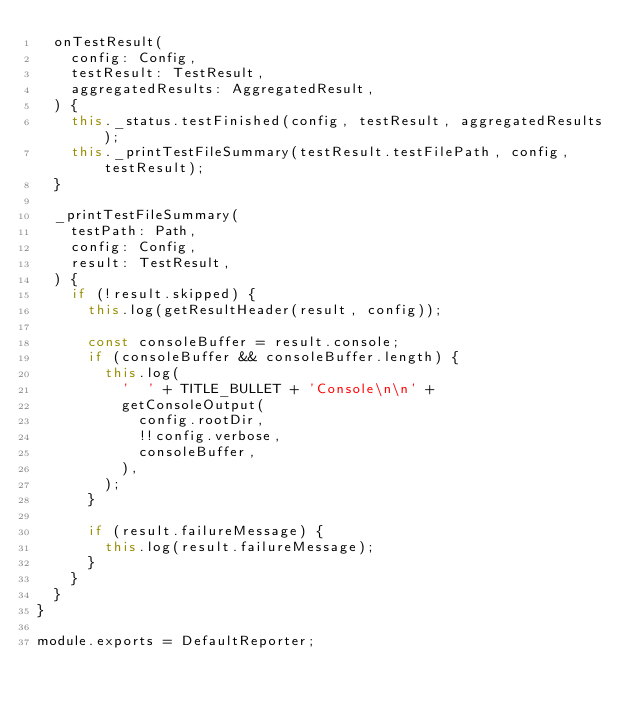<code> <loc_0><loc_0><loc_500><loc_500><_JavaScript_>  onTestResult(
    config: Config,
    testResult: TestResult,
    aggregatedResults: AggregatedResult,
  ) {
    this._status.testFinished(config, testResult, aggregatedResults);
    this._printTestFileSummary(testResult.testFilePath, config, testResult);
  }

  _printTestFileSummary(
    testPath: Path,
    config: Config,
    result: TestResult,
  ) {
    if (!result.skipped) {
      this.log(getResultHeader(result, config));

      const consoleBuffer = result.console;
      if (consoleBuffer && consoleBuffer.length) {
        this.log(
          '  ' + TITLE_BULLET + 'Console\n\n' +
          getConsoleOutput(
            config.rootDir,
            !!config.verbose,
            consoleBuffer,
          ),
        );
      }

      if (result.failureMessage) {
        this.log(result.failureMessage);
      }
    }
  }
}

module.exports = DefaultReporter;
</code> 